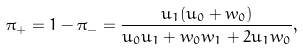<formula> <loc_0><loc_0><loc_500><loc_500>\pi _ { + } = 1 - \pi _ { - } = \frac { u _ { 1 } ( u _ { 0 } + w _ { 0 } ) } { u _ { 0 } u _ { 1 } + w _ { 0 } w _ { 1 } + 2 u _ { 1 } w _ { 0 } } ,</formula> 